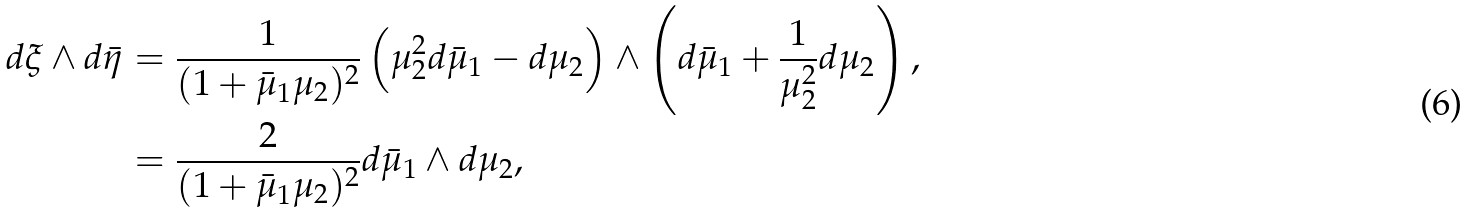<formula> <loc_0><loc_0><loc_500><loc_500>d \xi \wedge d \bar { \eta } & = \frac { 1 } { ( 1 + \bar { \mu } _ { 1 } \mu _ { 2 } ) ^ { 2 } } \left ( \mu _ { 2 } ^ { 2 } d \bar { \mu } _ { 1 } - d \mu _ { 2 } \right ) \wedge \left ( d \bar { \mu } _ { 1 } + \frac { 1 } { \mu _ { 2 } ^ { 2 } } d \mu _ { 2 } \right ) , \\ & = \frac { 2 } { ( 1 + \bar { \mu } _ { 1 } \mu _ { 2 } ) ^ { 2 } } d \bar { \mu } _ { 1 } \wedge d \mu _ { 2 } ,</formula> 